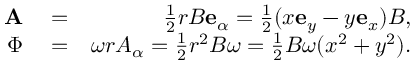<formula> <loc_0><loc_0><loc_500><loc_500>\begin{array} { r l r } { A } & = } & { \frac { 1 } { 2 } r B e _ { \alpha } = \frac { 1 } { 2 } ( x e _ { y } - y e _ { x } ) B , } \\ { \Phi } & = } & { \omega r A _ { \alpha } = \frac { 1 } { 2 } r ^ { 2 } B \omega = \frac { 1 } { 2 } B \omega ( x ^ { 2 } + y ^ { 2 } ) . } \end{array}</formula> 